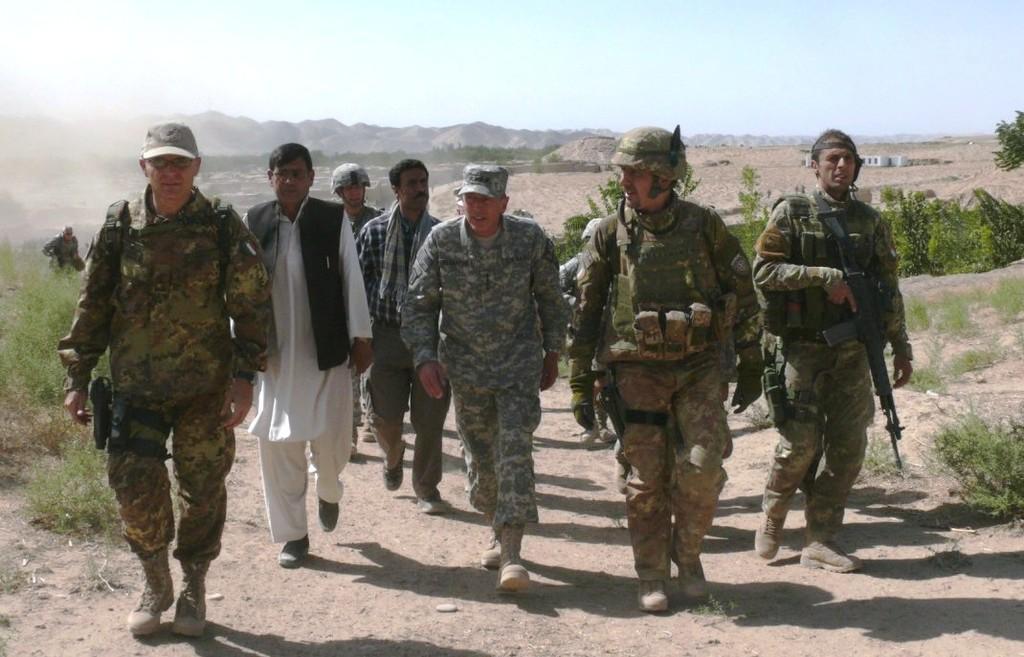Please provide a concise description of this image. In this image, we can see a group of people are walking through the walkway. Here we can see plants and ground. In the background, there are so many trees, houses, hills and sky. 